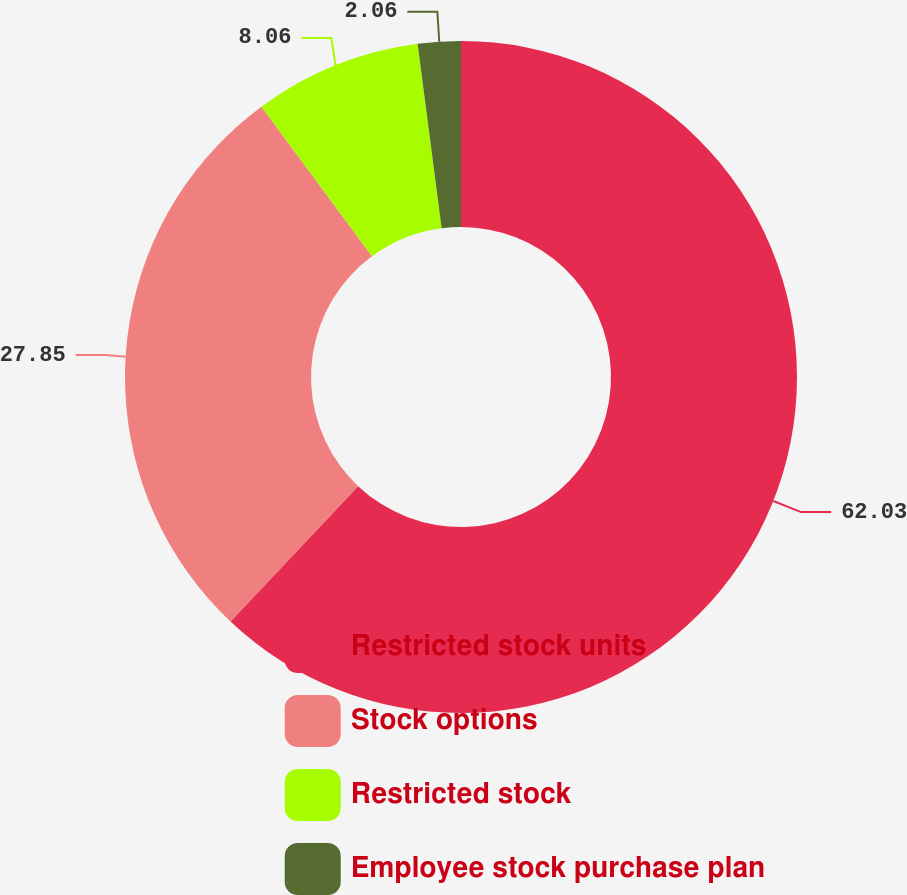<chart> <loc_0><loc_0><loc_500><loc_500><pie_chart><fcel>Restricted stock units<fcel>Stock options<fcel>Restricted stock<fcel>Employee stock purchase plan<nl><fcel>62.04%<fcel>27.85%<fcel>8.06%<fcel>2.06%<nl></chart> 